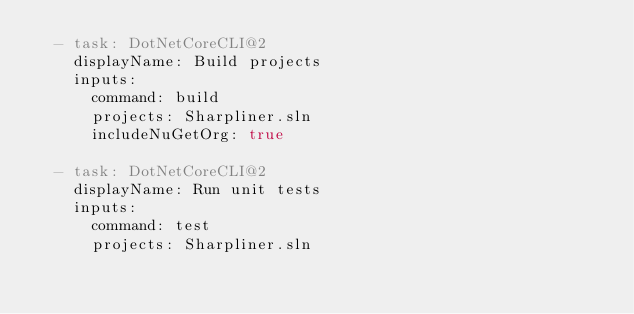<code> <loc_0><loc_0><loc_500><loc_500><_YAML_>  - task: DotNetCoreCLI@2
    displayName: Build projects
    inputs:
      command: build
      projects: Sharpliner.sln
      includeNuGetOrg: true

  - task: DotNetCoreCLI@2
    displayName: Run unit tests
    inputs:
      command: test
      projects: Sharpliner.sln
</code> 